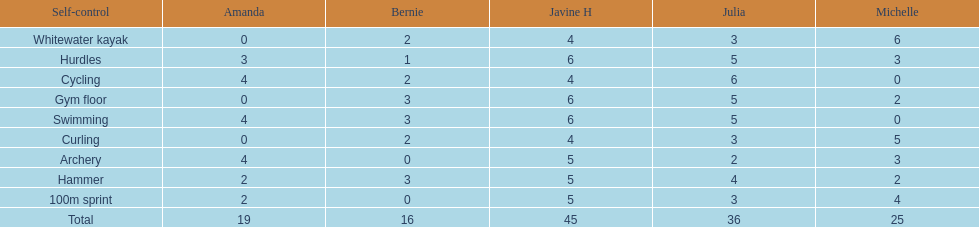Parse the table in full. {'header': ['Self-control', 'Amanda', 'Bernie', 'Javine H', 'Julia', 'Michelle'], 'rows': [['Whitewater kayak', '0', '2', '4', '3', '6'], ['Hurdles', '3', '1', '6', '5', '3'], ['Cycling', '4', '2', '4', '6', '0'], ['Gym floor', '0', '3', '6', '5', '2'], ['Swimming', '4', '3', '6', '5', '0'], ['Curling', '0', '2', '4', '3', '5'], ['Archery', '4', '0', '5', '2', '3'], ['Hammer', '2', '3', '5', '4', '2'], ['100m sprint', '2', '0', '5', '3', '4'], ['Total', '19', '16', '45', '36', '25']]} Name a girl that had the same score in cycling and archery. Amanda. 